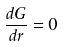<formula> <loc_0><loc_0><loc_500><loc_500>\frac { d G } { d r } = 0</formula> 